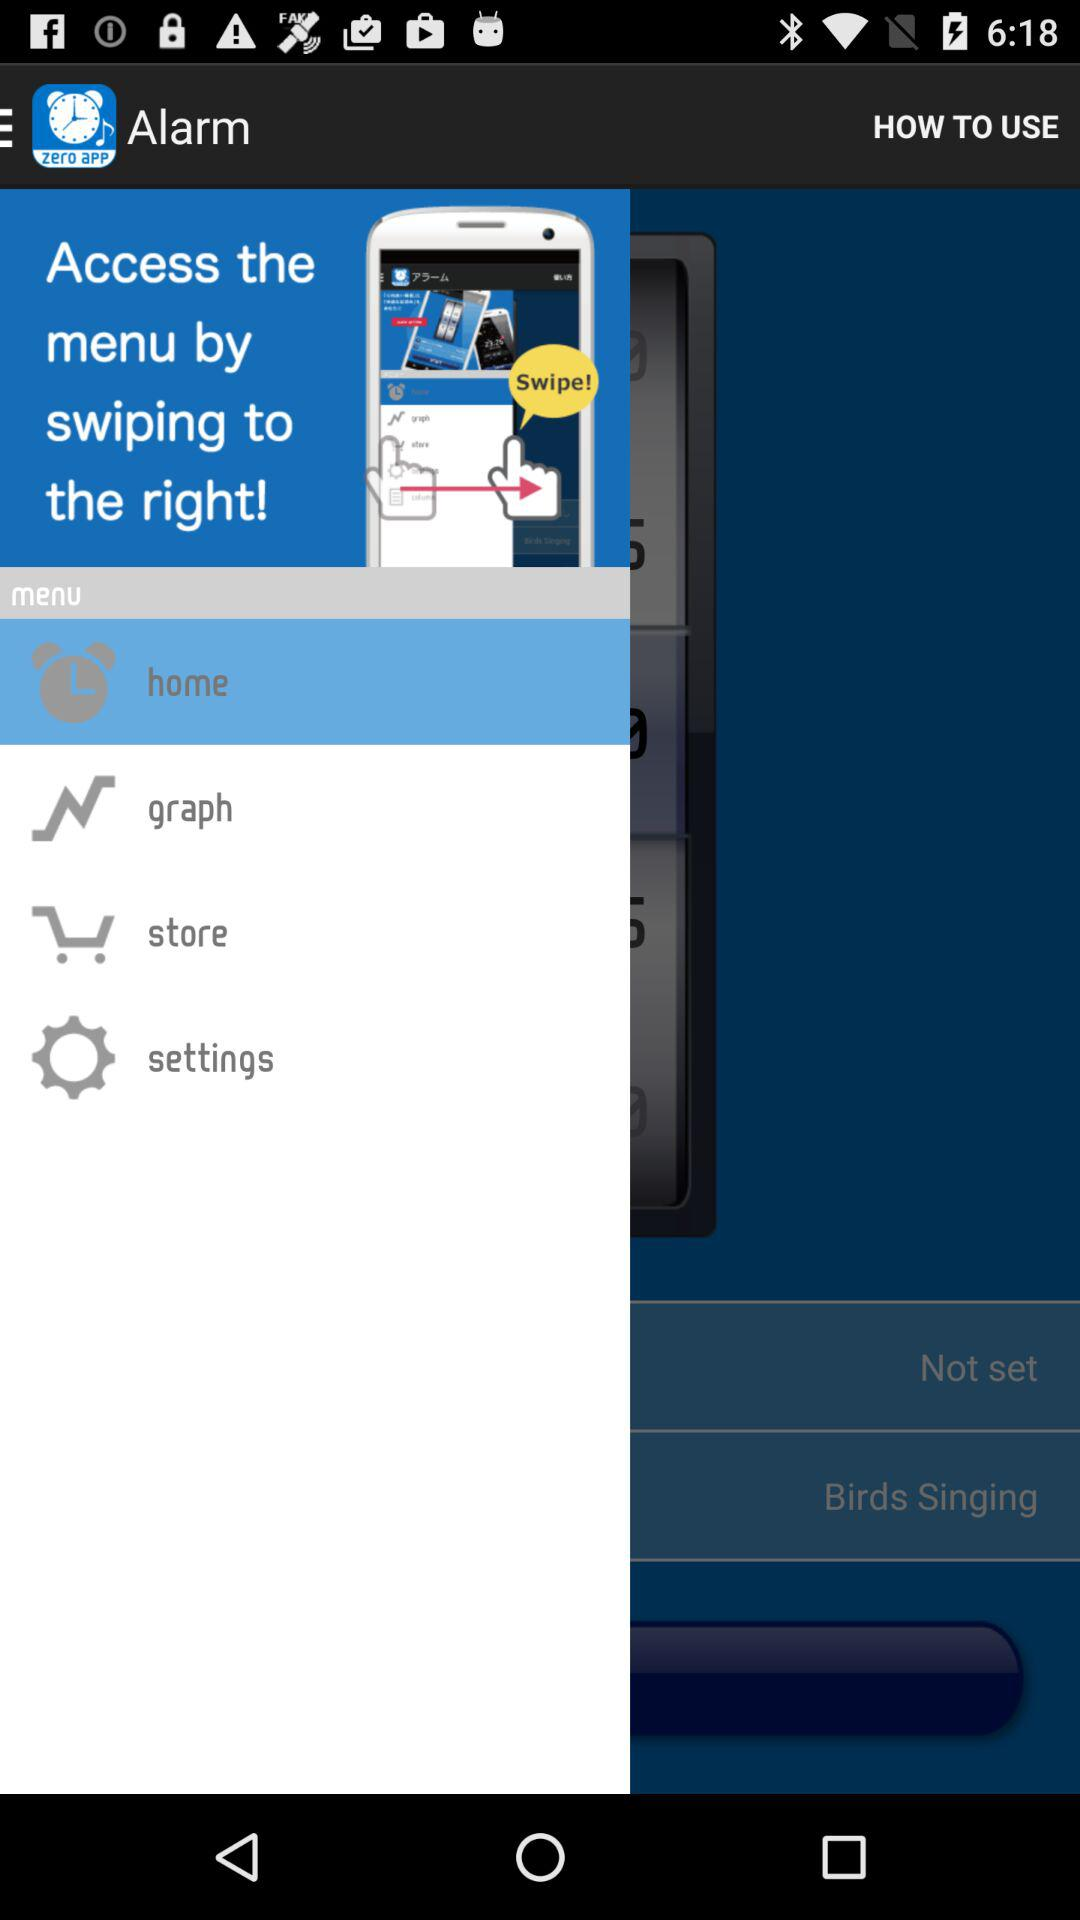How many items are in the menu?
Answer the question using a single word or phrase. 4 